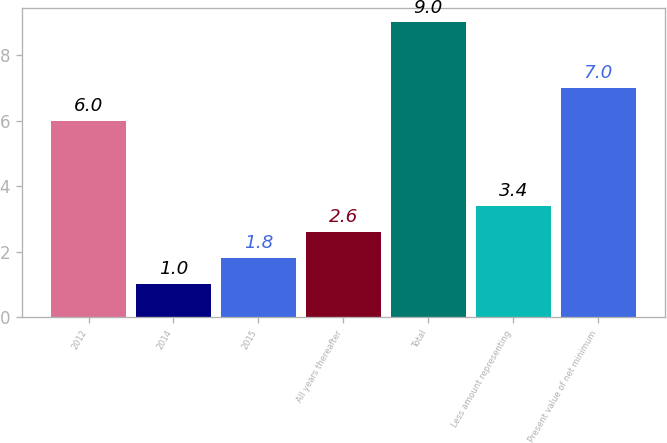<chart> <loc_0><loc_0><loc_500><loc_500><bar_chart><fcel>2012<fcel>2014<fcel>2015<fcel>All years thereafter<fcel>Total<fcel>Less amount representing<fcel>Present value of net minimum<nl><fcel>6<fcel>1<fcel>1.8<fcel>2.6<fcel>9<fcel>3.4<fcel>7<nl></chart> 